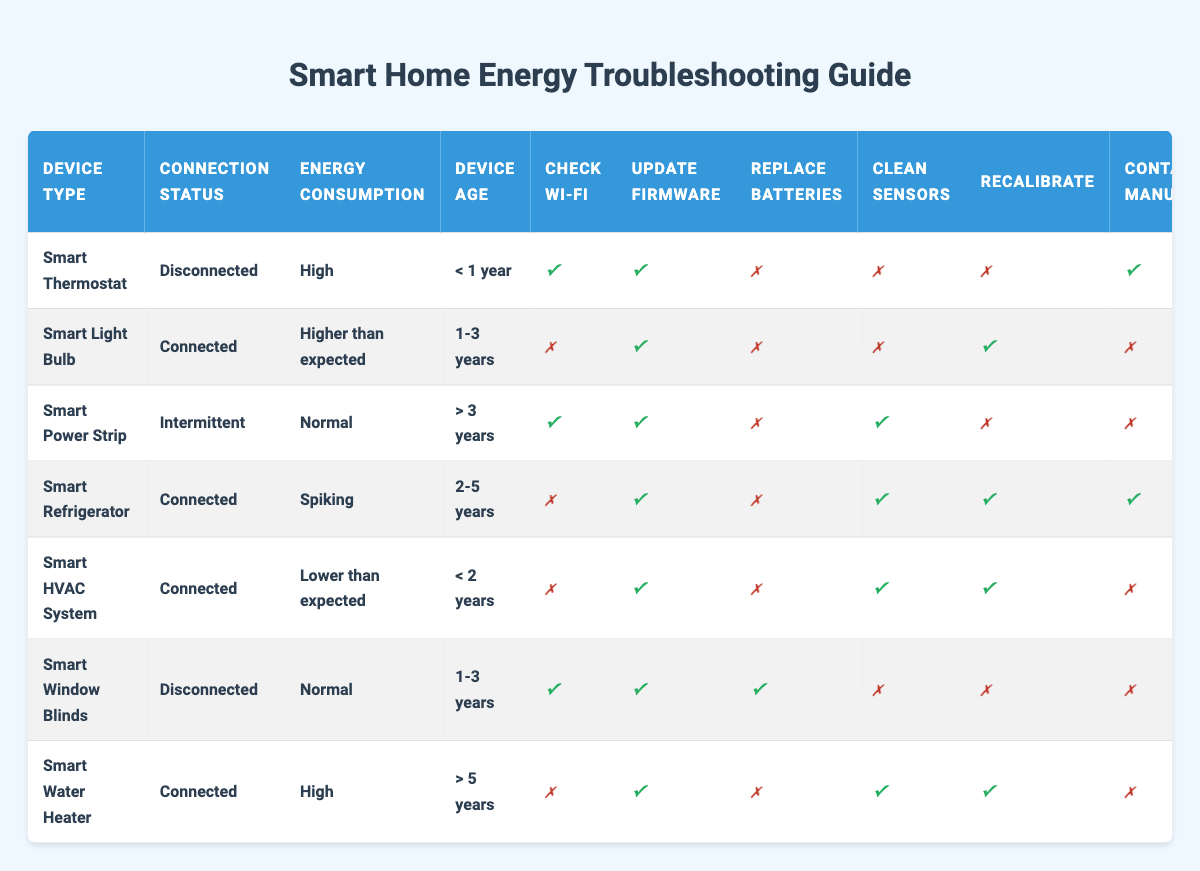What actions should be taken for a Smart Thermostat that is Disconnected and has High energy consumption? According to the table, for a Smart Thermostat with the conditions of being Disconnected and having High energy consumption, the recommended actions are: check Wi-Fi, update firmware, and contact the manufacturer.
Answer: Check Wi-Fi, update firmware, contact manufacturer What is the connection status for Smart Power Strip? By looking at the Smart Power Strip row in the table, we can see that its connection status is Intermittent.
Answer: Intermittent Are there any actions recommended for a Smart Refrigerator that is Connected and experiencing spiking energy consumption? The table indicates that for a Smart Refrigerator that is Connected and has spiking energy consumption, the actions recommended are to update firmware, clean sensors, recalibrate, contact the manufacturer, and schedule a professional inspection.
Answer: Update firmware, clean sensors, recalibrate, contact manufacturer, schedule inspection How many devices listed have an Energy Consumption marked as Normal? From the table, there are two devices with Normal energy consumption: Smart Power Strip and Smart Window Blinds. Thus, the count is 2.
Answer: 2 Is it recommended to replace batteries for devices older than 3 years that are connected and have high energy consumption? The Smart Water Heater is the only device older than 5 years and is connected with high energy consumption; however, replacing the batteries is not recommended as per table.
Answer: No What should you do if a Smart Window Blinds reports as Disconnected and has normal energy consumption? The actions for a Smart Window Blinds that is Disconnected and has normal energy consumption include checking Wi-Fi, updating firmware, and replacing batteries; cleaning sensors and recalibrating are not required.
Answer: Check Wi-Fi, update firmware, replace batteries For devices aged between 1 and 3 years with higher than expected energy consumption, what should be done? The table suggests for a Smart Light Bulb aged 1-3 years with higher than expected energy consumption to update firmware and recalibrate. Other actions are not required.
Answer: Update firmware, recalibrate How does the energy consumption of a Smart HVAC System compare to a Smart Refrigerator with the same connection status? The Smart HVAC System has lower than expected energy consumption whereas the Smart Refrigerator shows spiking energy consumption; hence, the HVAC system consumes less energy than the refrigerator.
Answer: HVAC system's energy consumption is lower Is it true that all devices older than 3 years should have their sensors cleaned? According to the table, only the Smart Power Strip recommends cleaning sensors, while the Smart Water Heater does as well, hence not all older devices recommend cleaning.
Answer: False 